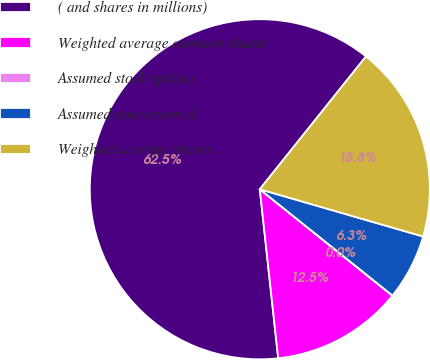Convert chart. <chart><loc_0><loc_0><loc_500><loc_500><pie_chart><fcel>( and shares in millions)<fcel>Weighted average common shares<fcel>Assumed stock options<fcel>Assumed conversion of<fcel>Weighted average shares<nl><fcel>62.46%<fcel>12.51%<fcel>0.02%<fcel>6.26%<fcel>18.75%<nl></chart> 